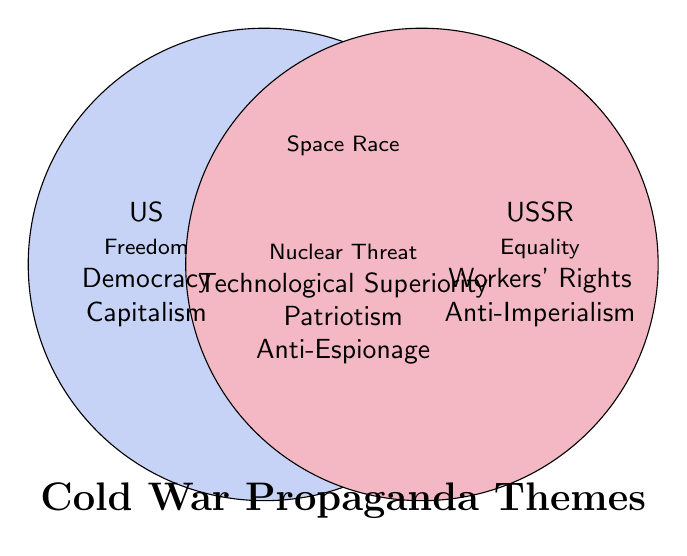What theme is shared between both the US and the USSR? The theme shared between both the US and the USSR falls in the overlapping section of the Venn diagram. Here, "Space Race" is the theme that appears in the intersection.
Answer: Space Race Which propaganda theme focuses on the protection of national interests and security against foreign intelligence efforts for both the US and the USSR? In the overlapping section of the Venn diagram, "Anti-Espionage" is listed among other shared themes.
Answer: Anti-Espionage Name two themes unique to the US propaganda. The themes unique to the US are in the left non-overlapping section of the Venn diagram. These include "Freedom" and "Democracy."
Answer: Freedom, Democracy How many themes are exclusively attributed to the USSR? In the right non-overlapping section of the Venn diagram, the themes exclusive to the USSR are "Equality," "Workers' Rights," and "Anti-Imperialism"—three themes in total.
Answer: 3 Identify the themes common to both countries that address advancements in science and defense. In the overlapping section, the themes reflecting advancements in science and defense are "Technological Superiority" and "Nuclear Threat."
Answer: Technological Superiority, Nuclear Threat 